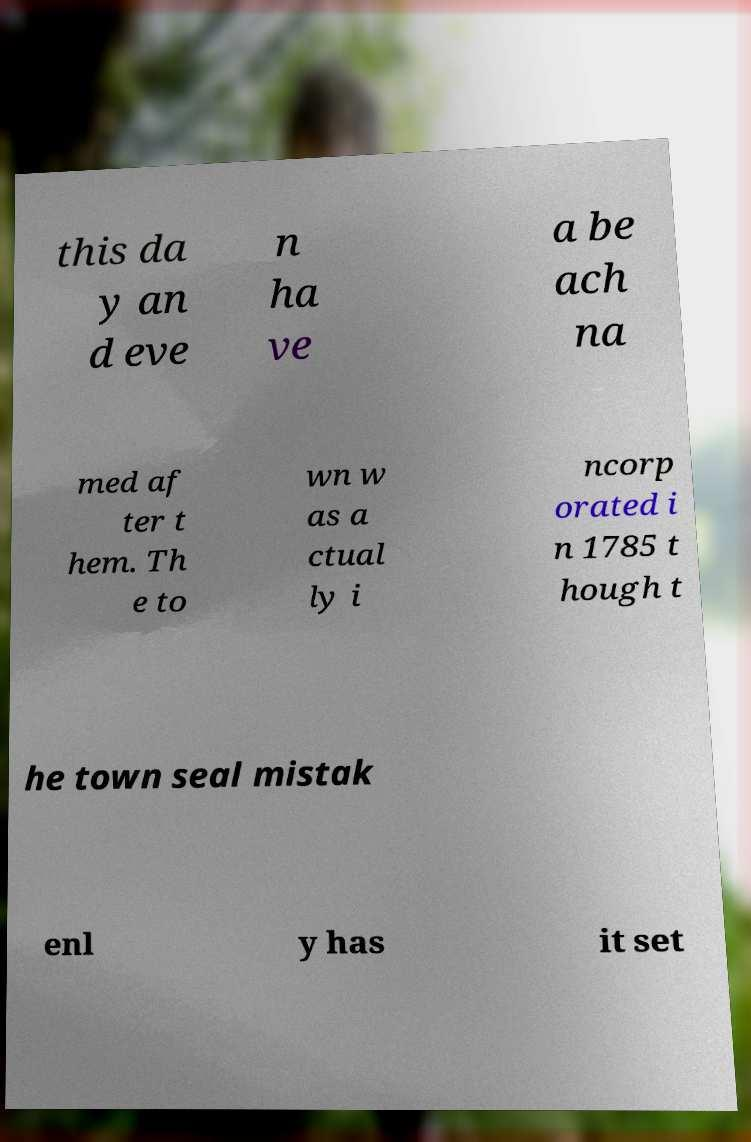There's text embedded in this image that I need extracted. Can you transcribe it verbatim? this da y an d eve n ha ve a be ach na med af ter t hem. Th e to wn w as a ctual ly i ncorp orated i n 1785 t hough t he town seal mistak enl y has it set 